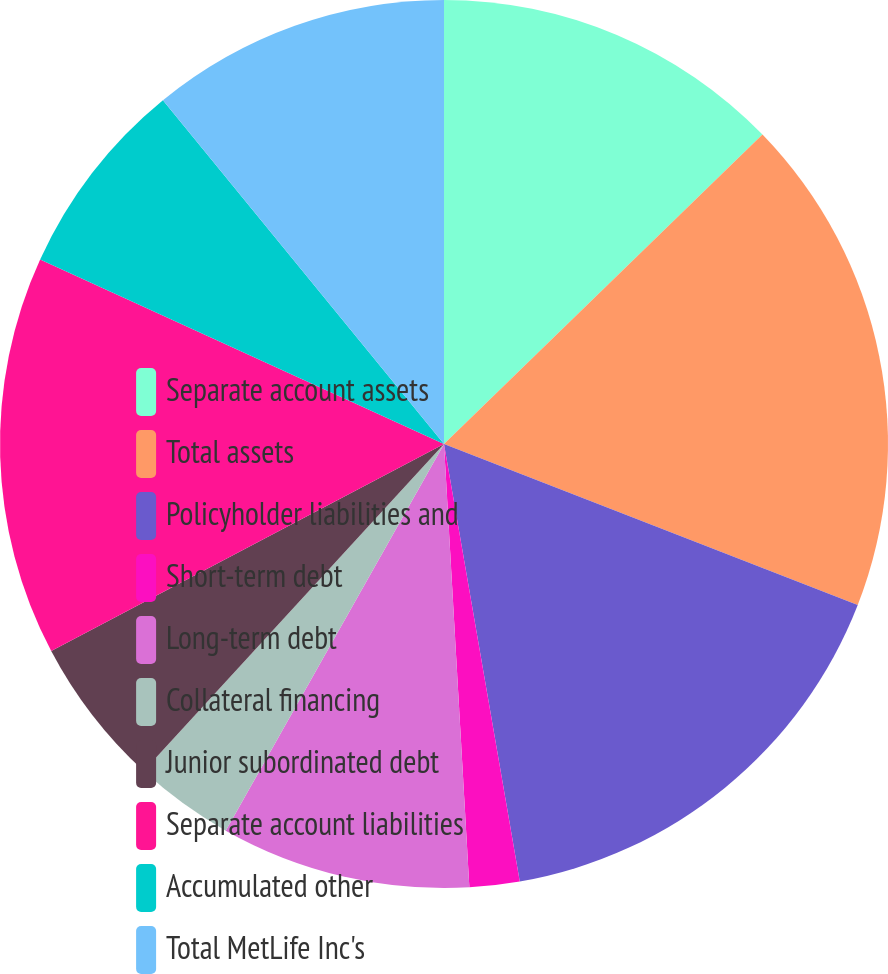Convert chart to OTSL. <chart><loc_0><loc_0><loc_500><loc_500><pie_chart><fcel>Separate account assets<fcel>Total assets<fcel>Policyholder liabilities and<fcel>Short-term debt<fcel>Long-term debt<fcel>Collateral financing<fcel>Junior subordinated debt<fcel>Separate account liabilities<fcel>Accumulated other<fcel>Total MetLife Inc's<nl><fcel>12.73%<fcel>18.18%<fcel>16.36%<fcel>1.82%<fcel>9.09%<fcel>3.64%<fcel>5.46%<fcel>14.54%<fcel>7.27%<fcel>10.91%<nl></chart> 